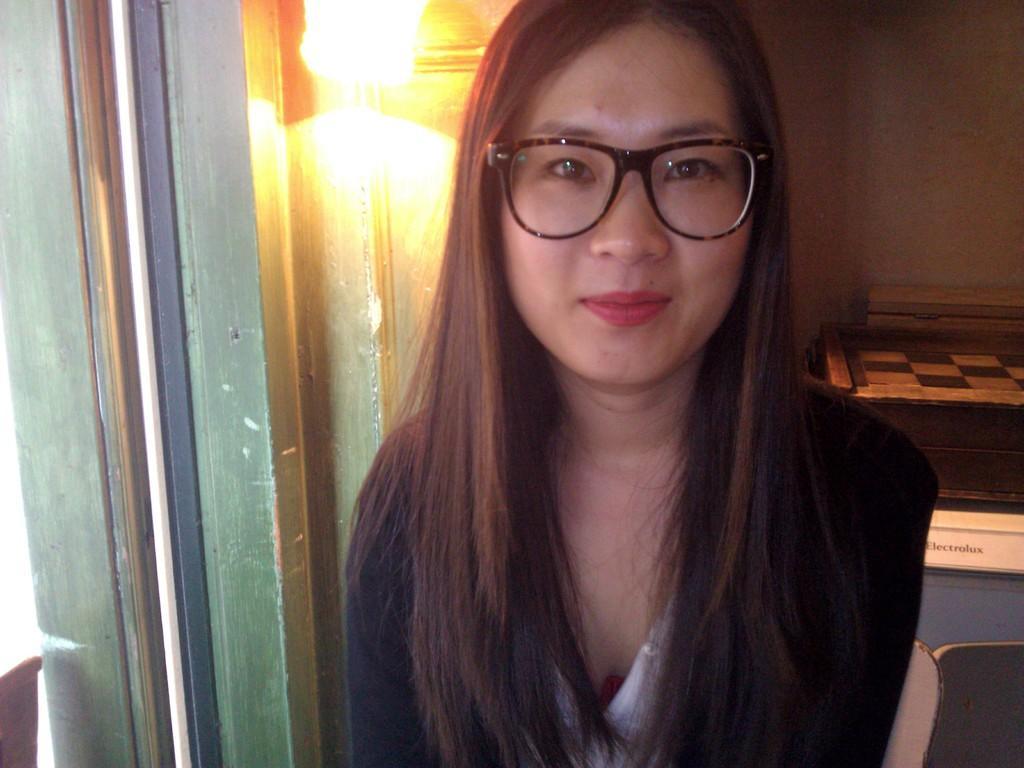Could you give a brief overview of what you see in this image? In this picture we can see a woman is smiling in the front, she wore spectacles, in the background there is a light and a wall, on the right side there is a name board. 